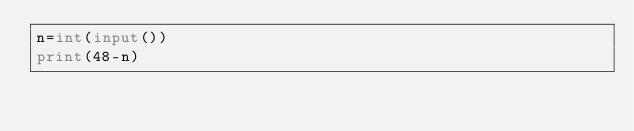<code> <loc_0><loc_0><loc_500><loc_500><_Python_>n=int(input())
print(48-n)
</code> 